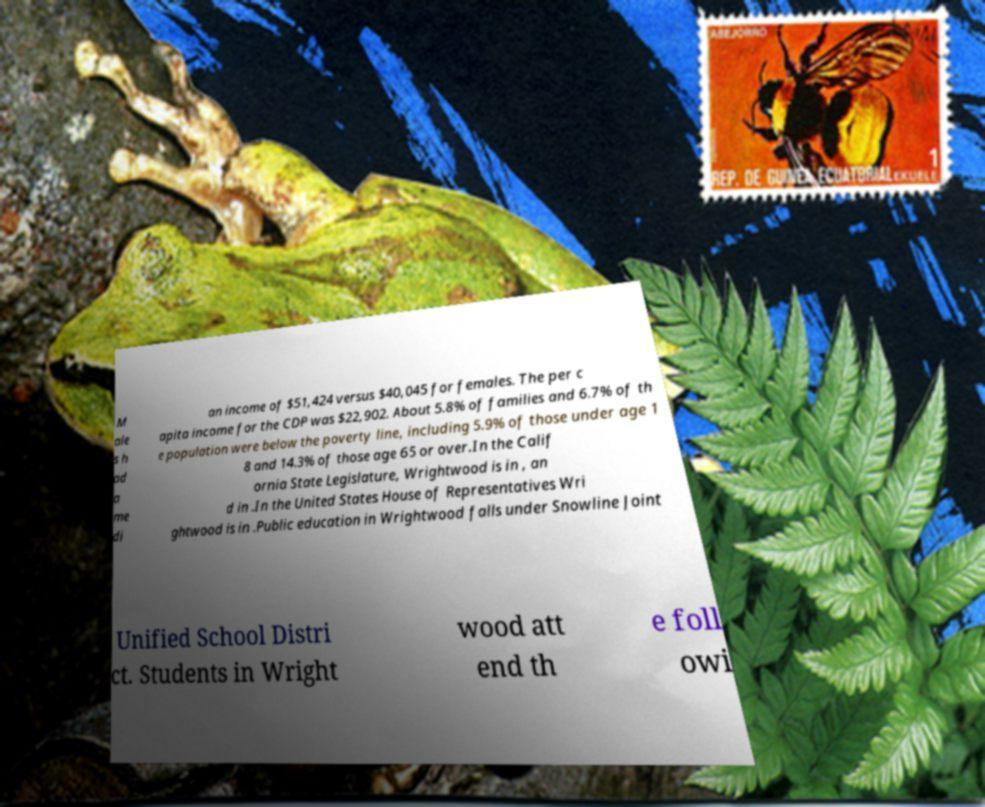Please identify and transcribe the text found in this image. M ale s h ad a me di an income of $51,424 versus $40,045 for females. The per c apita income for the CDP was $22,902. About 5.8% of families and 6.7% of th e population were below the poverty line, including 5.9% of those under age 1 8 and 14.3% of those age 65 or over.In the Calif ornia State Legislature, Wrightwood is in , an d in .In the United States House of Representatives Wri ghtwood is in .Public education in Wrightwood falls under Snowline Joint Unified School Distri ct. Students in Wright wood att end th e foll owi 